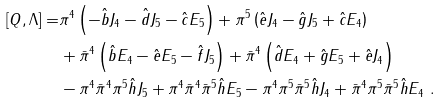<formula> <loc_0><loc_0><loc_500><loc_500>[ Q , \Lambda ] = & \pi ^ { 4 } \left ( - \hat { b } J _ { 4 } - \hat { d } J _ { 5 } - \hat { c } E _ { 5 } \right ) + \pi ^ { 5 } \left ( \hat { e } J _ { 4 } - \hat { g } J _ { 5 } + \hat { c } E _ { 4 } \right ) \\ & + \bar { \pi } ^ { 4 } \left ( \hat { b } E _ { 4 } - \hat { e } E _ { 5 } - \hat { f } J _ { 5 } \right ) + \bar { \pi } ^ { 4 } \left ( \hat { d } E _ { 4 } + \hat { g } E _ { 5 } + \hat { e } J _ { 4 } \right ) \\ & - \pi ^ { 4 } \bar { \pi } ^ { 4 } \pi ^ { 5 } \hat { h } J _ { 5 } + \pi ^ { 4 } \bar { \pi } ^ { 4 } \bar { \pi } ^ { 5 } \hat { h } E _ { 5 } - \pi ^ { 4 } \pi ^ { 5 } \bar { \pi } ^ { 5 } \hat { h } J _ { 4 } + \bar { \pi } ^ { 4 } \pi ^ { 5 } \bar { \pi } ^ { 5 } \hat { h } E _ { 4 } \ .</formula> 